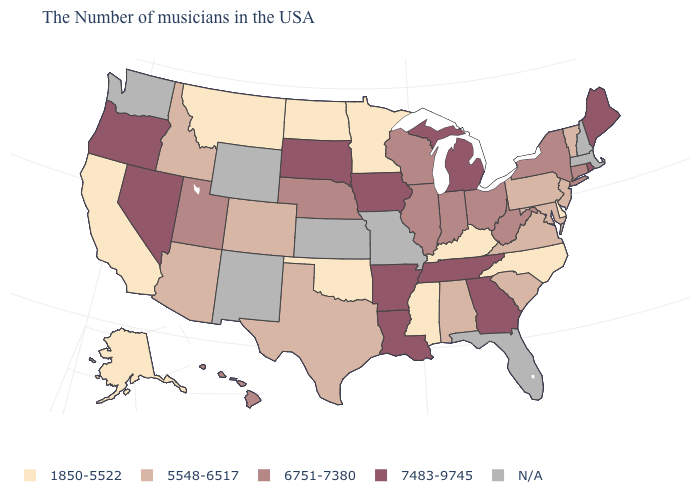How many symbols are there in the legend?
Be succinct. 5. What is the value of Oregon?
Short answer required. 7483-9745. Name the states that have a value in the range 1850-5522?
Quick response, please. Delaware, North Carolina, Kentucky, Mississippi, Minnesota, Oklahoma, North Dakota, Montana, California, Alaska. How many symbols are there in the legend?
Quick response, please. 5. What is the highest value in the USA?
Answer briefly. 7483-9745. Does the map have missing data?
Short answer required. Yes. Name the states that have a value in the range 1850-5522?
Short answer required. Delaware, North Carolina, Kentucky, Mississippi, Minnesota, Oklahoma, North Dakota, Montana, California, Alaska. Does Kentucky have the lowest value in the South?
Concise answer only. Yes. Name the states that have a value in the range 7483-9745?
Short answer required. Maine, Rhode Island, Georgia, Michigan, Tennessee, Louisiana, Arkansas, Iowa, South Dakota, Nevada, Oregon. Which states hav the highest value in the Northeast?
Quick response, please. Maine, Rhode Island. What is the lowest value in the MidWest?
Concise answer only. 1850-5522. Name the states that have a value in the range 1850-5522?
Concise answer only. Delaware, North Carolina, Kentucky, Mississippi, Minnesota, Oklahoma, North Dakota, Montana, California, Alaska. Name the states that have a value in the range 5548-6517?
Quick response, please. Vermont, New Jersey, Maryland, Pennsylvania, Virginia, South Carolina, Alabama, Texas, Colorado, Arizona, Idaho. 